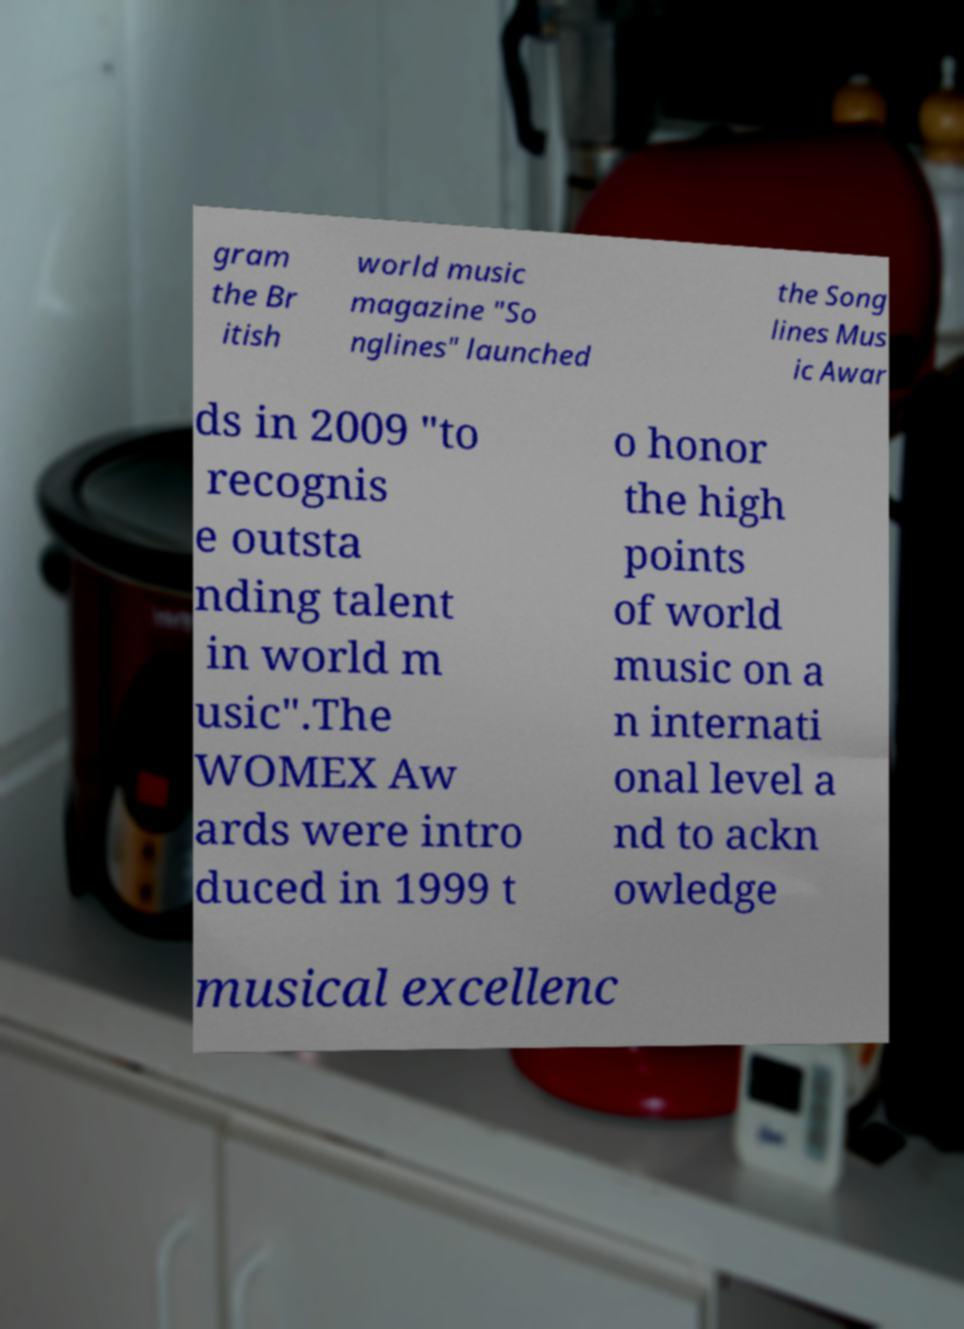I need the written content from this picture converted into text. Can you do that? gram the Br itish world music magazine "So nglines" launched the Song lines Mus ic Awar ds in 2009 "to recognis e outsta nding talent in world m usic".The WOMEX Aw ards were intro duced in 1999 t o honor the high points of world music on a n internati onal level a nd to ackn owledge musical excellenc 